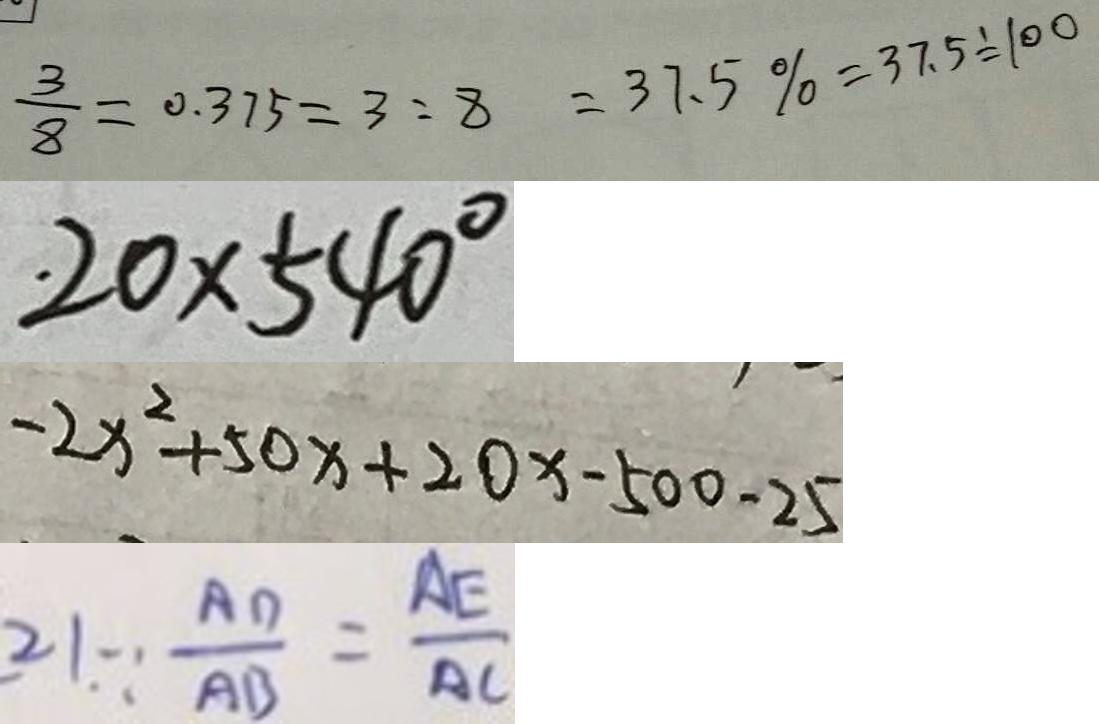Convert formula to latex. <formula><loc_0><loc_0><loc_500><loc_500>\frac { 3 } { 8 } = 0 . 3 7 5 = 3 : 8 = 3 7 . 5 \% = 3 7 . 5 \div 1 0 0 
 2 0 \times 5 4 0 ^ { \circ } 
 - 2 x ^ { 2 } + 5 0 x + 2 0 x - 5 0 0 - 2 5 
 2 1 . \because \frac { A D } { A B } = \frac { A E } { A C }</formula> 